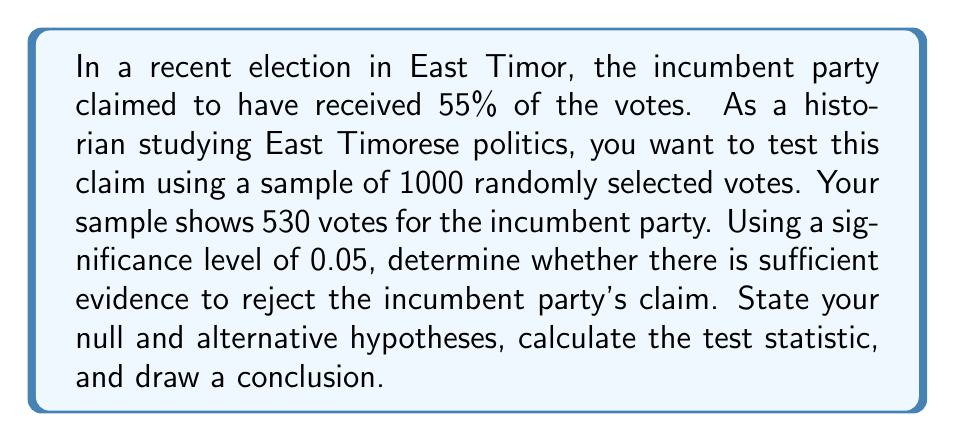Give your solution to this math problem. To solve this problem, we'll use a hypothesis test for a population proportion. Let's follow these steps:

1) State the hypotheses:
   $H_0: p = 0.55$ (null hypothesis)
   $H_a: p \neq 0.55$ (alternative hypothesis)

   Where $p$ is the true proportion of votes for the incumbent party.

2) Calculate the sample proportion:
   $\hat{p} = \frac{530}{1000} = 0.53$

3) Calculate the standard error under $H_0$:
   $SE = \sqrt{\frac{p_0(1-p_0)}{n}} = \sqrt{\frac{0.55(1-0.55)}{1000}} = 0.0157$

4) Calculate the z-score:
   $$z = \frac{\hat{p} - p_0}{SE} = \frac{0.53 - 0.55}{0.0157} = -1.27$$

5) Find the critical values:
   For a two-tailed test with $\alpha = 0.05$, the critical z-values are $\pm 1.96$.

6) Make a decision:
   Since $|-1.27| < 1.96$, we fail to reject the null hypothesis.

7) Calculate the p-value:
   $p\text{-value} = 2P(Z < -1.27) = 2(0.1020) = 0.2040$

   This can be found using a standard normal distribution table or calculator.

Conclusion: At a 5% significance level, we do not have sufficient evidence to reject the incumbent party's claim of receiving 55% of the votes. The sample data is consistent with the claimed proportion.

This analysis is crucial for understanding the political landscape of East Timor, as it provides a statistical basis for evaluating election claims and their potential impact on the country's democratic processes.
Answer: Fail to reject the null hypothesis. There is insufficient evidence to conclude that the true proportion of votes for the incumbent party is different from 55% (p-value = 0.2040 > 0.05). 